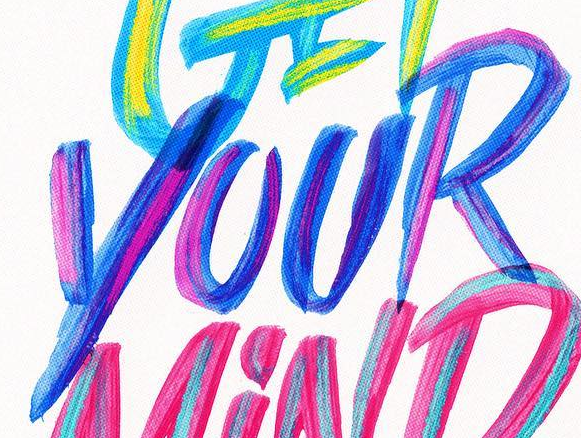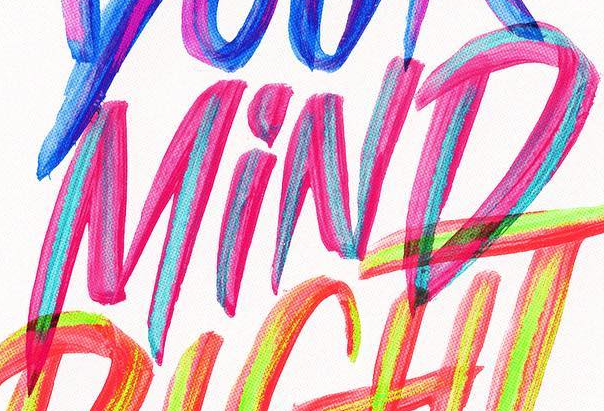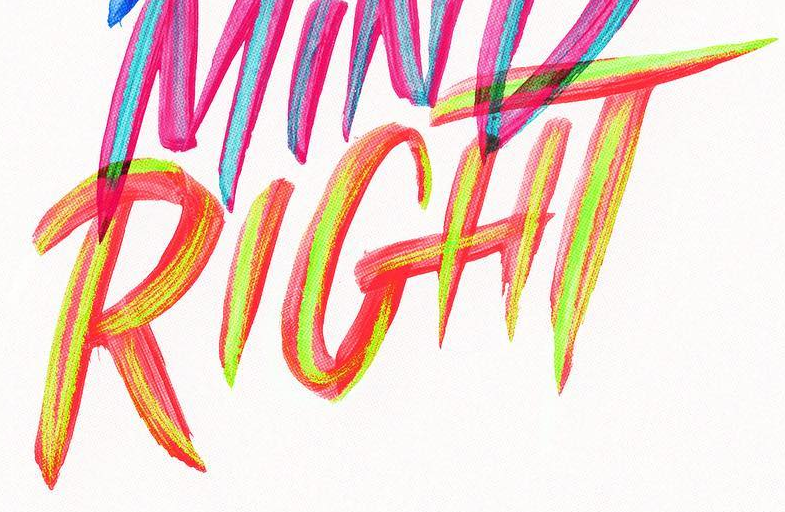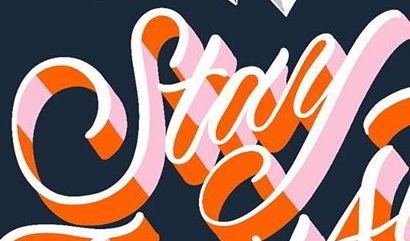What text appears in these images from left to right, separated by a semicolon? YOUR; MiND; RIGHT; Stay 